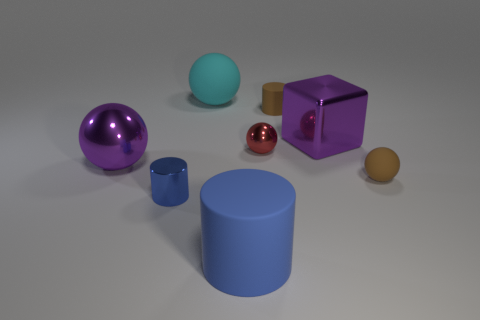There is a thing that is the same color as the large metal sphere; what is it made of?
Give a very brief answer. Metal. There is a big thing that is right of the blue matte cylinder; what is its color?
Provide a succinct answer. Purple. What number of purple objects are there?
Provide a succinct answer. 2. Is there a large cyan object that is on the left side of the metal thing that is on the right side of the small brown object that is on the left side of the purple metallic block?
Make the answer very short. Yes. What shape is the blue matte thing that is the same size as the purple ball?
Ensure brevity in your answer.  Cylinder. What number of other things are the same color as the large matte ball?
Keep it short and to the point. 0. What is the material of the big purple block?
Keep it short and to the point. Metal. What size is the ball that is on the left side of the large blue cylinder and in front of the large cyan matte ball?
Make the answer very short. Large. There is a brown matte thing to the right of the tiny brown matte object behind the large metal cube; what is its shape?
Provide a succinct answer. Sphere. Are there any other things that have the same shape as the cyan thing?
Offer a terse response. Yes. 